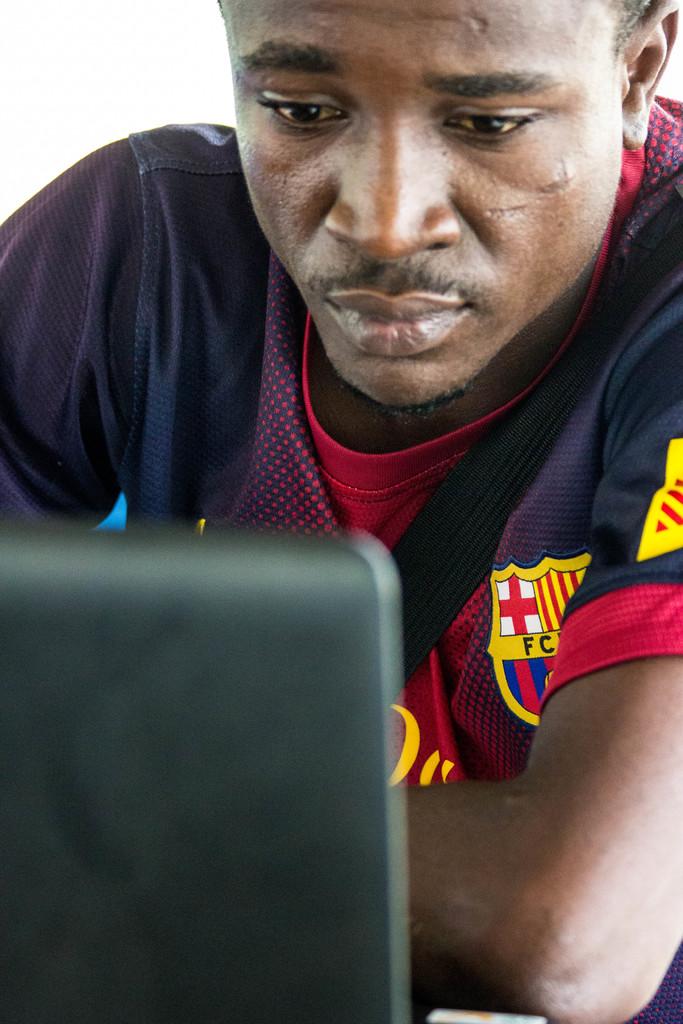What two letters can we see below the cross?
Make the answer very short. Fc. 